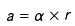Convert formula to latex. <formula><loc_0><loc_0><loc_500><loc_500>a = { \alpha } \times r</formula> 